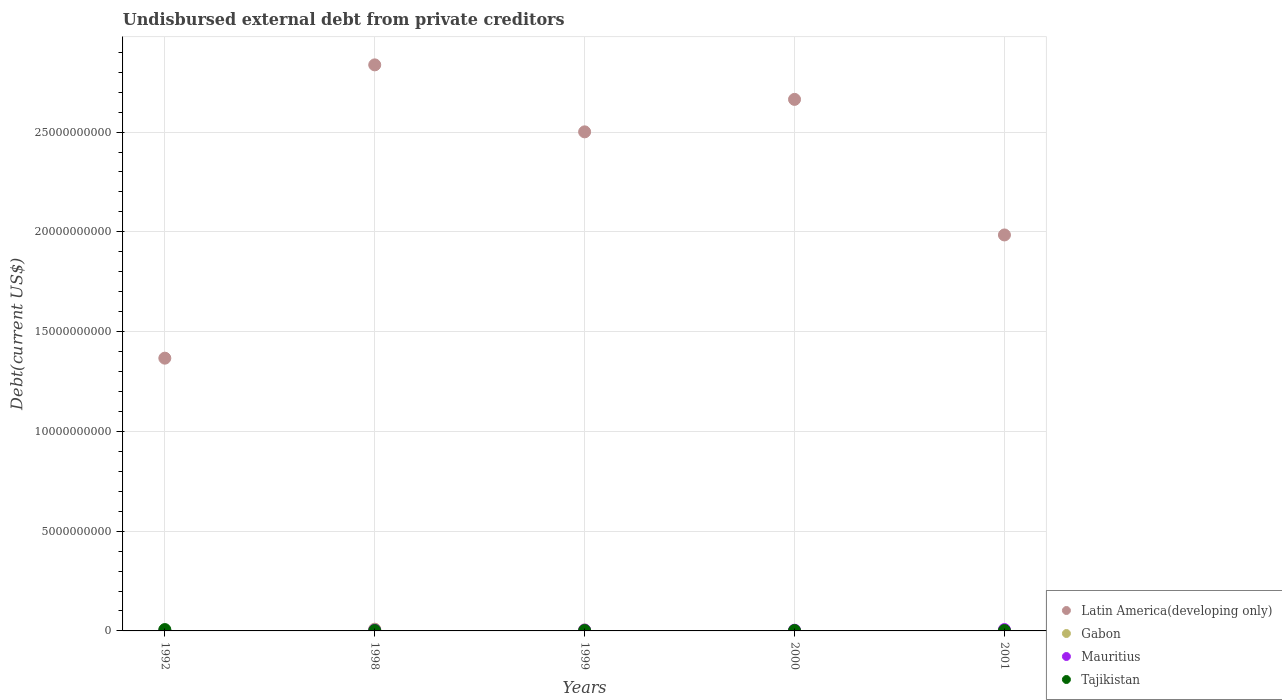How many different coloured dotlines are there?
Your response must be concise. 4. Is the number of dotlines equal to the number of legend labels?
Your answer should be very brief. Yes. What is the total debt in Gabon in 1999?
Give a very brief answer. 4.81e+07. Across all years, what is the maximum total debt in Mauritius?
Keep it short and to the point. 6.81e+07. Across all years, what is the minimum total debt in Tajikistan?
Ensure brevity in your answer.  2.00e+07. In which year was the total debt in Latin America(developing only) maximum?
Ensure brevity in your answer.  1998. What is the total total debt in Latin America(developing only) in the graph?
Make the answer very short. 1.14e+11. What is the difference between the total debt in Tajikistan in 1992 and that in 1998?
Your response must be concise. 4.80e+07. What is the difference between the total debt in Latin America(developing only) in 1998 and the total debt in Gabon in 2001?
Make the answer very short. 2.84e+1. What is the average total debt in Latin America(developing only) per year?
Give a very brief answer. 2.27e+1. In the year 2001, what is the difference between the total debt in Latin America(developing only) and total debt in Gabon?
Keep it short and to the point. 1.98e+1. In how many years, is the total debt in Gabon greater than 3000000000 US$?
Provide a succinct answer. 0. What is the ratio of the total debt in Latin America(developing only) in 1999 to that in 2001?
Your answer should be very brief. 1.26. What is the difference between the highest and the second highest total debt in Gabon?
Give a very brief answer. 3.90e+07. What is the difference between the highest and the lowest total debt in Gabon?
Ensure brevity in your answer.  8.37e+07. Is it the case that in every year, the sum of the total debt in Latin America(developing only) and total debt in Mauritius  is greater than the total debt in Gabon?
Your answer should be very brief. Yes. Is the total debt in Latin America(developing only) strictly greater than the total debt in Mauritius over the years?
Give a very brief answer. Yes. How many dotlines are there?
Give a very brief answer. 4. How many years are there in the graph?
Give a very brief answer. 5. Does the graph contain grids?
Offer a terse response. Yes. What is the title of the graph?
Your answer should be very brief. Undisbursed external debt from private creditors. What is the label or title of the X-axis?
Offer a very short reply. Years. What is the label or title of the Y-axis?
Your answer should be compact. Debt(current US$). What is the Debt(current US$) in Latin America(developing only) in 1992?
Offer a terse response. 1.37e+1. What is the Debt(current US$) in Gabon in 1992?
Offer a very short reply. 4.90e+06. What is the Debt(current US$) of Mauritius in 1992?
Ensure brevity in your answer.  1.92e+07. What is the Debt(current US$) of Tajikistan in 1992?
Give a very brief answer. 6.80e+07. What is the Debt(current US$) of Latin America(developing only) in 1998?
Provide a succinct answer. 2.84e+1. What is the Debt(current US$) in Gabon in 1998?
Make the answer very short. 8.71e+07. What is the Debt(current US$) in Mauritius in 1998?
Give a very brief answer. 4.61e+07. What is the Debt(current US$) of Tajikistan in 1998?
Offer a very short reply. 2.00e+07. What is the Debt(current US$) in Latin America(developing only) in 1999?
Your answer should be compact. 2.50e+1. What is the Debt(current US$) in Gabon in 1999?
Ensure brevity in your answer.  4.81e+07. What is the Debt(current US$) in Mauritius in 1999?
Provide a succinct answer. 4.21e+07. What is the Debt(current US$) in Tajikistan in 1999?
Provide a succinct answer. 2.00e+07. What is the Debt(current US$) of Latin America(developing only) in 2000?
Your answer should be very brief. 2.66e+1. What is the Debt(current US$) in Gabon in 2000?
Your response must be concise. 1.65e+07. What is the Debt(current US$) of Mauritius in 2000?
Give a very brief answer. 3.61e+07. What is the Debt(current US$) of Latin America(developing only) in 2001?
Give a very brief answer. 1.98e+1. What is the Debt(current US$) in Gabon in 2001?
Your answer should be very brief. 3.40e+06. What is the Debt(current US$) in Mauritius in 2001?
Offer a terse response. 6.81e+07. What is the Debt(current US$) of Tajikistan in 2001?
Provide a short and direct response. 2.00e+07. Across all years, what is the maximum Debt(current US$) of Latin America(developing only)?
Keep it short and to the point. 2.84e+1. Across all years, what is the maximum Debt(current US$) of Gabon?
Provide a succinct answer. 8.71e+07. Across all years, what is the maximum Debt(current US$) of Mauritius?
Your answer should be very brief. 6.81e+07. Across all years, what is the maximum Debt(current US$) in Tajikistan?
Keep it short and to the point. 6.80e+07. Across all years, what is the minimum Debt(current US$) of Latin America(developing only)?
Make the answer very short. 1.37e+1. Across all years, what is the minimum Debt(current US$) of Gabon?
Your response must be concise. 3.40e+06. Across all years, what is the minimum Debt(current US$) of Mauritius?
Offer a terse response. 1.92e+07. What is the total Debt(current US$) of Latin America(developing only) in the graph?
Your response must be concise. 1.14e+11. What is the total Debt(current US$) of Gabon in the graph?
Ensure brevity in your answer.  1.60e+08. What is the total Debt(current US$) of Mauritius in the graph?
Provide a short and direct response. 2.12e+08. What is the total Debt(current US$) in Tajikistan in the graph?
Provide a succinct answer. 1.48e+08. What is the difference between the Debt(current US$) in Latin America(developing only) in 1992 and that in 1998?
Provide a short and direct response. -1.47e+1. What is the difference between the Debt(current US$) of Gabon in 1992 and that in 1998?
Your response must be concise. -8.22e+07. What is the difference between the Debt(current US$) in Mauritius in 1992 and that in 1998?
Keep it short and to the point. -2.69e+07. What is the difference between the Debt(current US$) of Tajikistan in 1992 and that in 1998?
Your response must be concise. 4.80e+07. What is the difference between the Debt(current US$) of Latin America(developing only) in 1992 and that in 1999?
Give a very brief answer. -1.13e+1. What is the difference between the Debt(current US$) of Gabon in 1992 and that in 1999?
Provide a succinct answer. -4.32e+07. What is the difference between the Debt(current US$) of Mauritius in 1992 and that in 1999?
Give a very brief answer. -2.29e+07. What is the difference between the Debt(current US$) of Tajikistan in 1992 and that in 1999?
Your answer should be compact. 4.80e+07. What is the difference between the Debt(current US$) in Latin America(developing only) in 1992 and that in 2000?
Offer a very short reply. -1.30e+1. What is the difference between the Debt(current US$) of Gabon in 1992 and that in 2000?
Keep it short and to the point. -1.16e+07. What is the difference between the Debt(current US$) of Mauritius in 1992 and that in 2000?
Make the answer very short. -1.69e+07. What is the difference between the Debt(current US$) of Tajikistan in 1992 and that in 2000?
Offer a very short reply. 4.80e+07. What is the difference between the Debt(current US$) of Latin America(developing only) in 1992 and that in 2001?
Make the answer very short. -6.17e+09. What is the difference between the Debt(current US$) of Gabon in 1992 and that in 2001?
Ensure brevity in your answer.  1.50e+06. What is the difference between the Debt(current US$) of Mauritius in 1992 and that in 2001?
Ensure brevity in your answer.  -4.89e+07. What is the difference between the Debt(current US$) in Tajikistan in 1992 and that in 2001?
Your answer should be compact. 4.80e+07. What is the difference between the Debt(current US$) in Latin America(developing only) in 1998 and that in 1999?
Make the answer very short. 3.36e+09. What is the difference between the Debt(current US$) in Gabon in 1998 and that in 1999?
Offer a terse response. 3.90e+07. What is the difference between the Debt(current US$) of Latin America(developing only) in 1998 and that in 2000?
Provide a short and direct response. 1.73e+09. What is the difference between the Debt(current US$) of Gabon in 1998 and that in 2000?
Keep it short and to the point. 7.06e+07. What is the difference between the Debt(current US$) in Tajikistan in 1998 and that in 2000?
Your answer should be compact. 0. What is the difference between the Debt(current US$) in Latin America(developing only) in 1998 and that in 2001?
Offer a terse response. 8.52e+09. What is the difference between the Debt(current US$) in Gabon in 1998 and that in 2001?
Offer a very short reply. 8.37e+07. What is the difference between the Debt(current US$) of Mauritius in 1998 and that in 2001?
Offer a terse response. -2.20e+07. What is the difference between the Debt(current US$) in Tajikistan in 1998 and that in 2001?
Your answer should be very brief. 0. What is the difference between the Debt(current US$) of Latin America(developing only) in 1999 and that in 2000?
Provide a succinct answer. -1.63e+09. What is the difference between the Debt(current US$) in Gabon in 1999 and that in 2000?
Make the answer very short. 3.16e+07. What is the difference between the Debt(current US$) of Mauritius in 1999 and that in 2000?
Your answer should be compact. 6.00e+06. What is the difference between the Debt(current US$) in Latin America(developing only) in 1999 and that in 2001?
Your answer should be very brief. 5.17e+09. What is the difference between the Debt(current US$) in Gabon in 1999 and that in 2001?
Give a very brief answer. 4.47e+07. What is the difference between the Debt(current US$) of Mauritius in 1999 and that in 2001?
Ensure brevity in your answer.  -2.60e+07. What is the difference between the Debt(current US$) in Tajikistan in 1999 and that in 2001?
Provide a short and direct response. 0. What is the difference between the Debt(current US$) of Latin America(developing only) in 2000 and that in 2001?
Provide a short and direct response. 6.79e+09. What is the difference between the Debt(current US$) in Gabon in 2000 and that in 2001?
Offer a terse response. 1.31e+07. What is the difference between the Debt(current US$) in Mauritius in 2000 and that in 2001?
Your response must be concise. -3.20e+07. What is the difference between the Debt(current US$) of Tajikistan in 2000 and that in 2001?
Provide a succinct answer. 0. What is the difference between the Debt(current US$) in Latin America(developing only) in 1992 and the Debt(current US$) in Gabon in 1998?
Give a very brief answer. 1.36e+1. What is the difference between the Debt(current US$) of Latin America(developing only) in 1992 and the Debt(current US$) of Mauritius in 1998?
Provide a short and direct response. 1.36e+1. What is the difference between the Debt(current US$) of Latin America(developing only) in 1992 and the Debt(current US$) of Tajikistan in 1998?
Offer a terse response. 1.36e+1. What is the difference between the Debt(current US$) of Gabon in 1992 and the Debt(current US$) of Mauritius in 1998?
Give a very brief answer. -4.12e+07. What is the difference between the Debt(current US$) of Gabon in 1992 and the Debt(current US$) of Tajikistan in 1998?
Make the answer very short. -1.51e+07. What is the difference between the Debt(current US$) in Mauritius in 1992 and the Debt(current US$) in Tajikistan in 1998?
Provide a short and direct response. -8.43e+05. What is the difference between the Debt(current US$) in Latin America(developing only) in 1992 and the Debt(current US$) in Gabon in 1999?
Provide a short and direct response. 1.36e+1. What is the difference between the Debt(current US$) in Latin America(developing only) in 1992 and the Debt(current US$) in Mauritius in 1999?
Offer a terse response. 1.36e+1. What is the difference between the Debt(current US$) in Latin America(developing only) in 1992 and the Debt(current US$) in Tajikistan in 1999?
Make the answer very short. 1.36e+1. What is the difference between the Debt(current US$) in Gabon in 1992 and the Debt(current US$) in Mauritius in 1999?
Provide a short and direct response. -3.72e+07. What is the difference between the Debt(current US$) of Gabon in 1992 and the Debt(current US$) of Tajikistan in 1999?
Give a very brief answer. -1.51e+07. What is the difference between the Debt(current US$) of Mauritius in 1992 and the Debt(current US$) of Tajikistan in 1999?
Offer a terse response. -8.43e+05. What is the difference between the Debt(current US$) of Latin America(developing only) in 1992 and the Debt(current US$) of Gabon in 2000?
Keep it short and to the point. 1.37e+1. What is the difference between the Debt(current US$) of Latin America(developing only) in 1992 and the Debt(current US$) of Mauritius in 2000?
Offer a terse response. 1.36e+1. What is the difference between the Debt(current US$) in Latin America(developing only) in 1992 and the Debt(current US$) in Tajikistan in 2000?
Your answer should be compact. 1.36e+1. What is the difference between the Debt(current US$) of Gabon in 1992 and the Debt(current US$) of Mauritius in 2000?
Offer a terse response. -3.12e+07. What is the difference between the Debt(current US$) in Gabon in 1992 and the Debt(current US$) in Tajikistan in 2000?
Offer a terse response. -1.51e+07. What is the difference between the Debt(current US$) of Mauritius in 1992 and the Debt(current US$) of Tajikistan in 2000?
Offer a very short reply. -8.43e+05. What is the difference between the Debt(current US$) of Latin America(developing only) in 1992 and the Debt(current US$) of Gabon in 2001?
Provide a short and direct response. 1.37e+1. What is the difference between the Debt(current US$) of Latin America(developing only) in 1992 and the Debt(current US$) of Mauritius in 2001?
Offer a terse response. 1.36e+1. What is the difference between the Debt(current US$) of Latin America(developing only) in 1992 and the Debt(current US$) of Tajikistan in 2001?
Provide a succinct answer. 1.36e+1. What is the difference between the Debt(current US$) of Gabon in 1992 and the Debt(current US$) of Mauritius in 2001?
Keep it short and to the point. -6.32e+07. What is the difference between the Debt(current US$) in Gabon in 1992 and the Debt(current US$) in Tajikistan in 2001?
Provide a succinct answer. -1.51e+07. What is the difference between the Debt(current US$) of Mauritius in 1992 and the Debt(current US$) of Tajikistan in 2001?
Your answer should be very brief. -8.43e+05. What is the difference between the Debt(current US$) of Latin America(developing only) in 1998 and the Debt(current US$) of Gabon in 1999?
Your response must be concise. 2.83e+1. What is the difference between the Debt(current US$) in Latin America(developing only) in 1998 and the Debt(current US$) in Mauritius in 1999?
Ensure brevity in your answer.  2.83e+1. What is the difference between the Debt(current US$) in Latin America(developing only) in 1998 and the Debt(current US$) in Tajikistan in 1999?
Give a very brief answer. 2.83e+1. What is the difference between the Debt(current US$) of Gabon in 1998 and the Debt(current US$) of Mauritius in 1999?
Keep it short and to the point. 4.50e+07. What is the difference between the Debt(current US$) in Gabon in 1998 and the Debt(current US$) in Tajikistan in 1999?
Keep it short and to the point. 6.71e+07. What is the difference between the Debt(current US$) in Mauritius in 1998 and the Debt(current US$) in Tajikistan in 1999?
Give a very brief answer. 2.61e+07. What is the difference between the Debt(current US$) of Latin America(developing only) in 1998 and the Debt(current US$) of Gabon in 2000?
Offer a terse response. 2.84e+1. What is the difference between the Debt(current US$) of Latin America(developing only) in 1998 and the Debt(current US$) of Mauritius in 2000?
Provide a succinct answer. 2.83e+1. What is the difference between the Debt(current US$) in Latin America(developing only) in 1998 and the Debt(current US$) in Tajikistan in 2000?
Offer a terse response. 2.83e+1. What is the difference between the Debt(current US$) of Gabon in 1998 and the Debt(current US$) of Mauritius in 2000?
Your response must be concise. 5.10e+07. What is the difference between the Debt(current US$) in Gabon in 1998 and the Debt(current US$) in Tajikistan in 2000?
Provide a succinct answer. 6.71e+07. What is the difference between the Debt(current US$) of Mauritius in 1998 and the Debt(current US$) of Tajikistan in 2000?
Make the answer very short. 2.61e+07. What is the difference between the Debt(current US$) of Latin America(developing only) in 1998 and the Debt(current US$) of Gabon in 2001?
Your response must be concise. 2.84e+1. What is the difference between the Debt(current US$) in Latin America(developing only) in 1998 and the Debt(current US$) in Mauritius in 2001?
Provide a short and direct response. 2.83e+1. What is the difference between the Debt(current US$) in Latin America(developing only) in 1998 and the Debt(current US$) in Tajikistan in 2001?
Give a very brief answer. 2.83e+1. What is the difference between the Debt(current US$) of Gabon in 1998 and the Debt(current US$) of Mauritius in 2001?
Provide a succinct answer. 1.90e+07. What is the difference between the Debt(current US$) in Gabon in 1998 and the Debt(current US$) in Tajikistan in 2001?
Your answer should be very brief. 6.71e+07. What is the difference between the Debt(current US$) of Mauritius in 1998 and the Debt(current US$) of Tajikistan in 2001?
Offer a terse response. 2.61e+07. What is the difference between the Debt(current US$) of Latin America(developing only) in 1999 and the Debt(current US$) of Gabon in 2000?
Keep it short and to the point. 2.50e+1. What is the difference between the Debt(current US$) of Latin America(developing only) in 1999 and the Debt(current US$) of Mauritius in 2000?
Give a very brief answer. 2.50e+1. What is the difference between the Debt(current US$) in Latin America(developing only) in 1999 and the Debt(current US$) in Tajikistan in 2000?
Provide a succinct answer. 2.50e+1. What is the difference between the Debt(current US$) in Gabon in 1999 and the Debt(current US$) in Mauritius in 2000?
Make the answer very short. 1.20e+07. What is the difference between the Debt(current US$) in Gabon in 1999 and the Debt(current US$) in Tajikistan in 2000?
Provide a short and direct response. 2.81e+07. What is the difference between the Debt(current US$) in Mauritius in 1999 and the Debt(current US$) in Tajikistan in 2000?
Provide a succinct answer. 2.21e+07. What is the difference between the Debt(current US$) in Latin America(developing only) in 1999 and the Debt(current US$) in Gabon in 2001?
Your answer should be very brief. 2.50e+1. What is the difference between the Debt(current US$) in Latin America(developing only) in 1999 and the Debt(current US$) in Mauritius in 2001?
Offer a very short reply. 2.49e+1. What is the difference between the Debt(current US$) of Latin America(developing only) in 1999 and the Debt(current US$) of Tajikistan in 2001?
Your response must be concise. 2.50e+1. What is the difference between the Debt(current US$) in Gabon in 1999 and the Debt(current US$) in Mauritius in 2001?
Provide a succinct answer. -2.00e+07. What is the difference between the Debt(current US$) of Gabon in 1999 and the Debt(current US$) of Tajikistan in 2001?
Your answer should be compact. 2.81e+07. What is the difference between the Debt(current US$) in Mauritius in 1999 and the Debt(current US$) in Tajikistan in 2001?
Your response must be concise. 2.21e+07. What is the difference between the Debt(current US$) of Latin America(developing only) in 2000 and the Debt(current US$) of Gabon in 2001?
Your answer should be very brief. 2.66e+1. What is the difference between the Debt(current US$) of Latin America(developing only) in 2000 and the Debt(current US$) of Mauritius in 2001?
Provide a succinct answer. 2.66e+1. What is the difference between the Debt(current US$) of Latin America(developing only) in 2000 and the Debt(current US$) of Tajikistan in 2001?
Your answer should be compact. 2.66e+1. What is the difference between the Debt(current US$) in Gabon in 2000 and the Debt(current US$) in Mauritius in 2001?
Your response must be concise. -5.16e+07. What is the difference between the Debt(current US$) in Gabon in 2000 and the Debt(current US$) in Tajikistan in 2001?
Your answer should be very brief. -3.48e+06. What is the difference between the Debt(current US$) in Mauritius in 2000 and the Debt(current US$) in Tajikistan in 2001?
Give a very brief answer. 1.61e+07. What is the average Debt(current US$) in Latin America(developing only) per year?
Offer a terse response. 2.27e+1. What is the average Debt(current US$) in Gabon per year?
Your answer should be very brief. 3.20e+07. What is the average Debt(current US$) in Mauritius per year?
Offer a terse response. 4.23e+07. What is the average Debt(current US$) in Tajikistan per year?
Give a very brief answer. 2.96e+07. In the year 1992, what is the difference between the Debt(current US$) of Latin America(developing only) and Debt(current US$) of Gabon?
Keep it short and to the point. 1.37e+1. In the year 1992, what is the difference between the Debt(current US$) in Latin America(developing only) and Debt(current US$) in Mauritius?
Ensure brevity in your answer.  1.36e+1. In the year 1992, what is the difference between the Debt(current US$) in Latin America(developing only) and Debt(current US$) in Tajikistan?
Provide a succinct answer. 1.36e+1. In the year 1992, what is the difference between the Debt(current US$) of Gabon and Debt(current US$) of Mauritius?
Offer a very short reply. -1.43e+07. In the year 1992, what is the difference between the Debt(current US$) in Gabon and Debt(current US$) in Tajikistan?
Keep it short and to the point. -6.31e+07. In the year 1992, what is the difference between the Debt(current US$) in Mauritius and Debt(current US$) in Tajikistan?
Make the answer very short. -4.88e+07. In the year 1998, what is the difference between the Debt(current US$) in Latin America(developing only) and Debt(current US$) in Gabon?
Offer a terse response. 2.83e+1. In the year 1998, what is the difference between the Debt(current US$) in Latin America(developing only) and Debt(current US$) in Mauritius?
Ensure brevity in your answer.  2.83e+1. In the year 1998, what is the difference between the Debt(current US$) in Latin America(developing only) and Debt(current US$) in Tajikistan?
Provide a short and direct response. 2.83e+1. In the year 1998, what is the difference between the Debt(current US$) of Gabon and Debt(current US$) of Mauritius?
Ensure brevity in your answer.  4.10e+07. In the year 1998, what is the difference between the Debt(current US$) of Gabon and Debt(current US$) of Tajikistan?
Offer a very short reply. 6.71e+07. In the year 1998, what is the difference between the Debt(current US$) in Mauritius and Debt(current US$) in Tajikistan?
Offer a terse response. 2.61e+07. In the year 1999, what is the difference between the Debt(current US$) of Latin America(developing only) and Debt(current US$) of Gabon?
Provide a short and direct response. 2.50e+1. In the year 1999, what is the difference between the Debt(current US$) in Latin America(developing only) and Debt(current US$) in Mauritius?
Give a very brief answer. 2.50e+1. In the year 1999, what is the difference between the Debt(current US$) of Latin America(developing only) and Debt(current US$) of Tajikistan?
Give a very brief answer. 2.50e+1. In the year 1999, what is the difference between the Debt(current US$) in Gabon and Debt(current US$) in Mauritius?
Offer a terse response. 6.00e+06. In the year 1999, what is the difference between the Debt(current US$) of Gabon and Debt(current US$) of Tajikistan?
Provide a succinct answer. 2.81e+07. In the year 1999, what is the difference between the Debt(current US$) of Mauritius and Debt(current US$) of Tajikistan?
Your answer should be compact. 2.21e+07. In the year 2000, what is the difference between the Debt(current US$) in Latin America(developing only) and Debt(current US$) in Gabon?
Your answer should be very brief. 2.66e+1. In the year 2000, what is the difference between the Debt(current US$) in Latin America(developing only) and Debt(current US$) in Mauritius?
Provide a succinct answer. 2.66e+1. In the year 2000, what is the difference between the Debt(current US$) in Latin America(developing only) and Debt(current US$) in Tajikistan?
Your answer should be compact. 2.66e+1. In the year 2000, what is the difference between the Debt(current US$) in Gabon and Debt(current US$) in Mauritius?
Your answer should be compact. -1.96e+07. In the year 2000, what is the difference between the Debt(current US$) in Gabon and Debt(current US$) in Tajikistan?
Offer a terse response. -3.48e+06. In the year 2000, what is the difference between the Debt(current US$) of Mauritius and Debt(current US$) of Tajikistan?
Keep it short and to the point. 1.61e+07. In the year 2001, what is the difference between the Debt(current US$) in Latin America(developing only) and Debt(current US$) in Gabon?
Offer a terse response. 1.98e+1. In the year 2001, what is the difference between the Debt(current US$) of Latin America(developing only) and Debt(current US$) of Mauritius?
Give a very brief answer. 1.98e+1. In the year 2001, what is the difference between the Debt(current US$) in Latin America(developing only) and Debt(current US$) in Tajikistan?
Offer a terse response. 1.98e+1. In the year 2001, what is the difference between the Debt(current US$) in Gabon and Debt(current US$) in Mauritius?
Your answer should be very brief. -6.47e+07. In the year 2001, what is the difference between the Debt(current US$) of Gabon and Debt(current US$) of Tajikistan?
Provide a short and direct response. -1.66e+07. In the year 2001, what is the difference between the Debt(current US$) of Mauritius and Debt(current US$) of Tajikistan?
Offer a very short reply. 4.81e+07. What is the ratio of the Debt(current US$) in Latin America(developing only) in 1992 to that in 1998?
Offer a very short reply. 0.48. What is the ratio of the Debt(current US$) of Gabon in 1992 to that in 1998?
Provide a short and direct response. 0.06. What is the ratio of the Debt(current US$) of Mauritius in 1992 to that in 1998?
Offer a very short reply. 0.42. What is the ratio of the Debt(current US$) in Latin America(developing only) in 1992 to that in 1999?
Provide a succinct answer. 0.55. What is the ratio of the Debt(current US$) in Gabon in 1992 to that in 1999?
Make the answer very short. 0.1. What is the ratio of the Debt(current US$) in Mauritius in 1992 to that in 1999?
Offer a very short reply. 0.46. What is the ratio of the Debt(current US$) in Latin America(developing only) in 1992 to that in 2000?
Your answer should be compact. 0.51. What is the ratio of the Debt(current US$) in Gabon in 1992 to that in 2000?
Make the answer very short. 0.3. What is the ratio of the Debt(current US$) of Mauritius in 1992 to that in 2000?
Offer a very short reply. 0.53. What is the ratio of the Debt(current US$) in Latin America(developing only) in 1992 to that in 2001?
Your answer should be very brief. 0.69. What is the ratio of the Debt(current US$) in Gabon in 1992 to that in 2001?
Give a very brief answer. 1.44. What is the ratio of the Debt(current US$) in Mauritius in 1992 to that in 2001?
Offer a very short reply. 0.28. What is the ratio of the Debt(current US$) of Latin America(developing only) in 1998 to that in 1999?
Your response must be concise. 1.13. What is the ratio of the Debt(current US$) of Gabon in 1998 to that in 1999?
Ensure brevity in your answer.  1.81. What is the ratio of the Debt(current US$) of Mauritius in 1998 to that in 1999?
Give a very brief answer. 1.09. What is the ratio of the Debt(current US$) in Tajikistan in 1998 to that in 1999?
Offer a terse response. 1. What is the ratio of the Debt(current US$) of Latin America(developing only) in 1998 to that in 2000?
Make the answer very short. 1.06. What is the ratio of the Debt(current US$) of Gabon in 1998 to that in 2000?
Provide a short and direct response. 5.27. What is the ratio of the Debt(current US$) of Mauritius in 1998 to that in 2000?
Provide a succinct answer. 1.28. What is the ratio of the Debt(current US$) in Tajikistan in 1998 to that in 2000?
Your answer should be very brief. 1. What is the ratio of the Debt(current US$) in Latin America(developing only) in 1998 to that in 2001?
Ensure brevity in your answer.  1.43. What is the ratio of the Debt(current US$) in Gabon in 1998 to that in 2001?
Make the answer very short. 25.63. What is the ratio of the Debt(current US$) of Mauritius in 1998 to that in 2001?
Your response must be concise. 0.68. What is the ratio of the Debt(current US$) of Latin America(developing only) in 1999 to that in 2000?
Your response must be concise. 0.94. What is the ratio of the Debt(current US$) in Gabon in 1999 to that in 2000?
Keep it short and to the point. 2.91. What is the ratio of the Debt(current US$) in Mauritius in 1999 to that in 2000?
Give a very brief answer. 1.17. What is the ratio of the Debt(current US$) of Latin America(developing only) in 1999 to that in 2001?
Provide a short and direct response. 1.26. What is the ratio of the Debt(current US$) in Gabon in 1999 to that in 2001?
Provide a succinct answer. 14.15. What is the ratio of the Debt(current US$) in Mauritius in 1999 to that in 2001?
Keep it short and to the point. 0.62. What is the ratio of the Debt(current US$) in Latin America(developing only) in 2000 to that in 2001?
Your response must be concise. 1.34. What is the ratio of the Debt(current US$) in Gabon in 2000 to that in 2001?
Ensure brevity in your answer.  4.86. What is the ratio of the Debt(current US$) of Mauritius in 2000 to that in 2001?
Provide a succinct answer. 0.53. What is the ratio of the Debt(current US$) in Tajikistan in 2000 to that in 2001?
Make the answer very short. 1. What is the difference between the highest and the second highest Debt(current US$) in Latin America(developing only)?
Your answer should be very brief. 1.73e+09. What is the difference between the highest and the second highest Debt(current US$) of Gabon?
Provide a succinct answer. 3.90e+07. What is the difference between the highest and the second highest Debt(current US$) in Mauritius?
Provide a succinct answer. 2.20e+07. What is the difference between the highest and the second highest Debt(current US$) in Tajikistan?
Keep it short and to the point. 4.80e+07. What is the difference between the highest and the lowest Debt(current US$) of Latin America(developing only)?
Give a very brief answer. 1.47e+1. What is the difference between the highest and the lowest Debt(current US$) of Gabon?
Your answer should be very brief. 8.37e+07. What is the difference between the highest and the lowest Debt(current US$) of Mauritius?
Keep it short and to the point. 4.89e+07. What is the difference between the highest and the lowest Debt(current US$) in Tajikistan?
Give a very brief answer. 4.80e+07. 